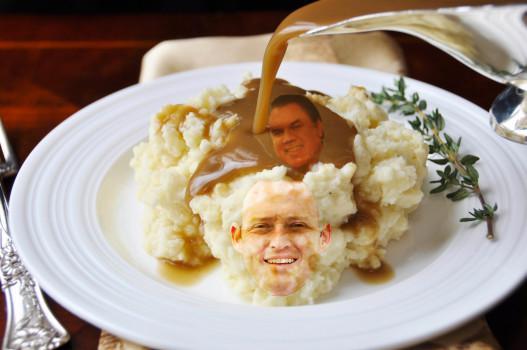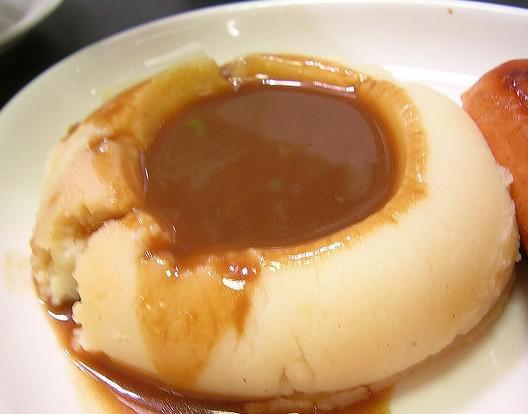The first image is the image on the left, the second image is the image on the right. Assess this claim about the two images: "the mashed potato on the right image is shaped like a bowl of gravy.". Correct or not? Answer yes or no. Yes. 